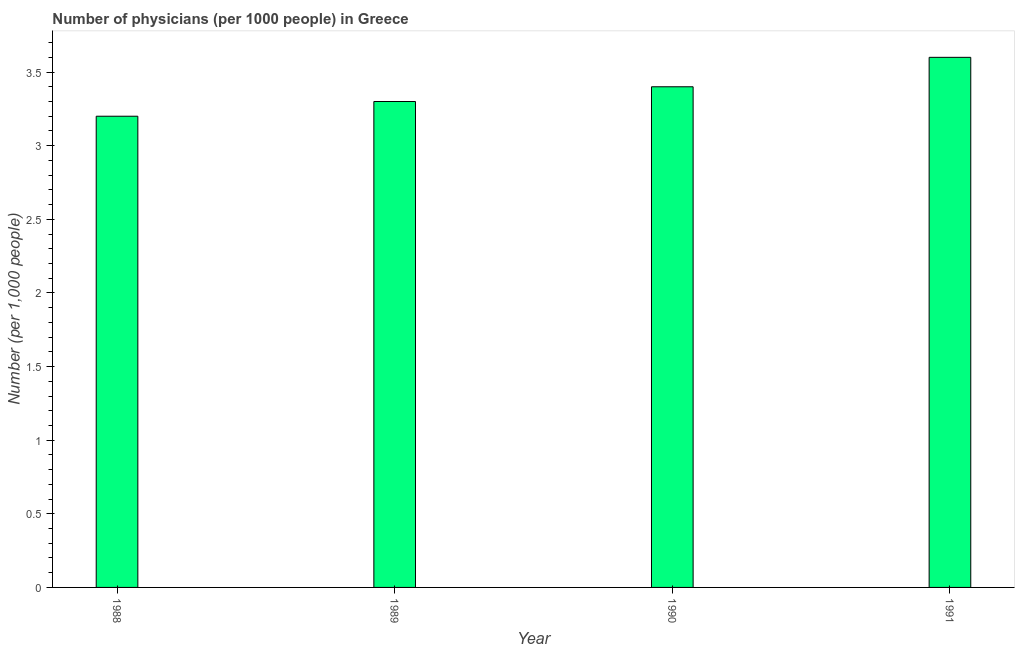What is the title of the graph?
Make the answer very short. Number of physicians (per 1000 people) in Greece. What is the label or title of the Y-axis?
Your answer should be compact. Number (per 1,0 people). Across all years, what is the maximum number of physicians?
Give a very brief answer. 3.6. In which year was the number of physicians minimum?
Your answer should be very brief. 1988. What is the average number of physicians per year?
Keep it short and to the point. 3.38. What is the median number of physicians?
Offer a very short reply. 3.35. Do a majority of the years between 1990 and 1989 (inclusive) have number of physicians greater than 3.3 ?
Keep it short and to the point. No. What is the ratio of the number of physicians in 1988 to that in 1991?
Your answer should be very brief. 0.89. Is the number of physicians in 1989 less than that in 1991?
Offer a very short reply. Yes. Is the difference between the number of physicians in 1988 and 1990 greater than the difference between any two years?
Your answer should be compact. No. Is the sum of the number of physicians in 1988 and 1991 greater than the maximum number of physicians across all years?
Your answer should be very brief. Yes. In how many years, is the number of physicians greater than the average number of physicians taken over all years?
Your answer should be very brief. 2. How many bars are there?
Offer a very short reply. 4. Are all the bars in the graph horizontal?
Offer a terse response. No. What is the difference between two consecutive major ticks on the Y-axis?
Your answer should be very brief. 0.5. What is the Number (per 1,000 people) of 1988?
Provide a succinct answer. 3.2. What is the difference between the Number (per 1,000 people) in 1988 and 1989?
Provide a short and direct response. -0.1. What is the difference between the Number (per 1,000 people) in 1988 and 1990?
Provide a succinct answer. -0.2. What is the ratio of the Number (per 1,000 people) in 1988 to that in 1989?
Give a very brief answer. 0.97. What is the ratio of the Number (per 1,000 people) in 1988 to that in 1990?
Provide a succinct answer. 0.94. What is the ratio of the Number (per 1,000 people) in 1988 to that in 1991?
Ensure brevity in your answer.  0.89. What is the ratio of the Number (per 1,000 people) in 1989 to that in 1991?
Offer a terse response. 0.92. What is the ratio of the Number (per 1,000 people) in 1990 to that in 1991?
Offer a very short reply. 0.94. 